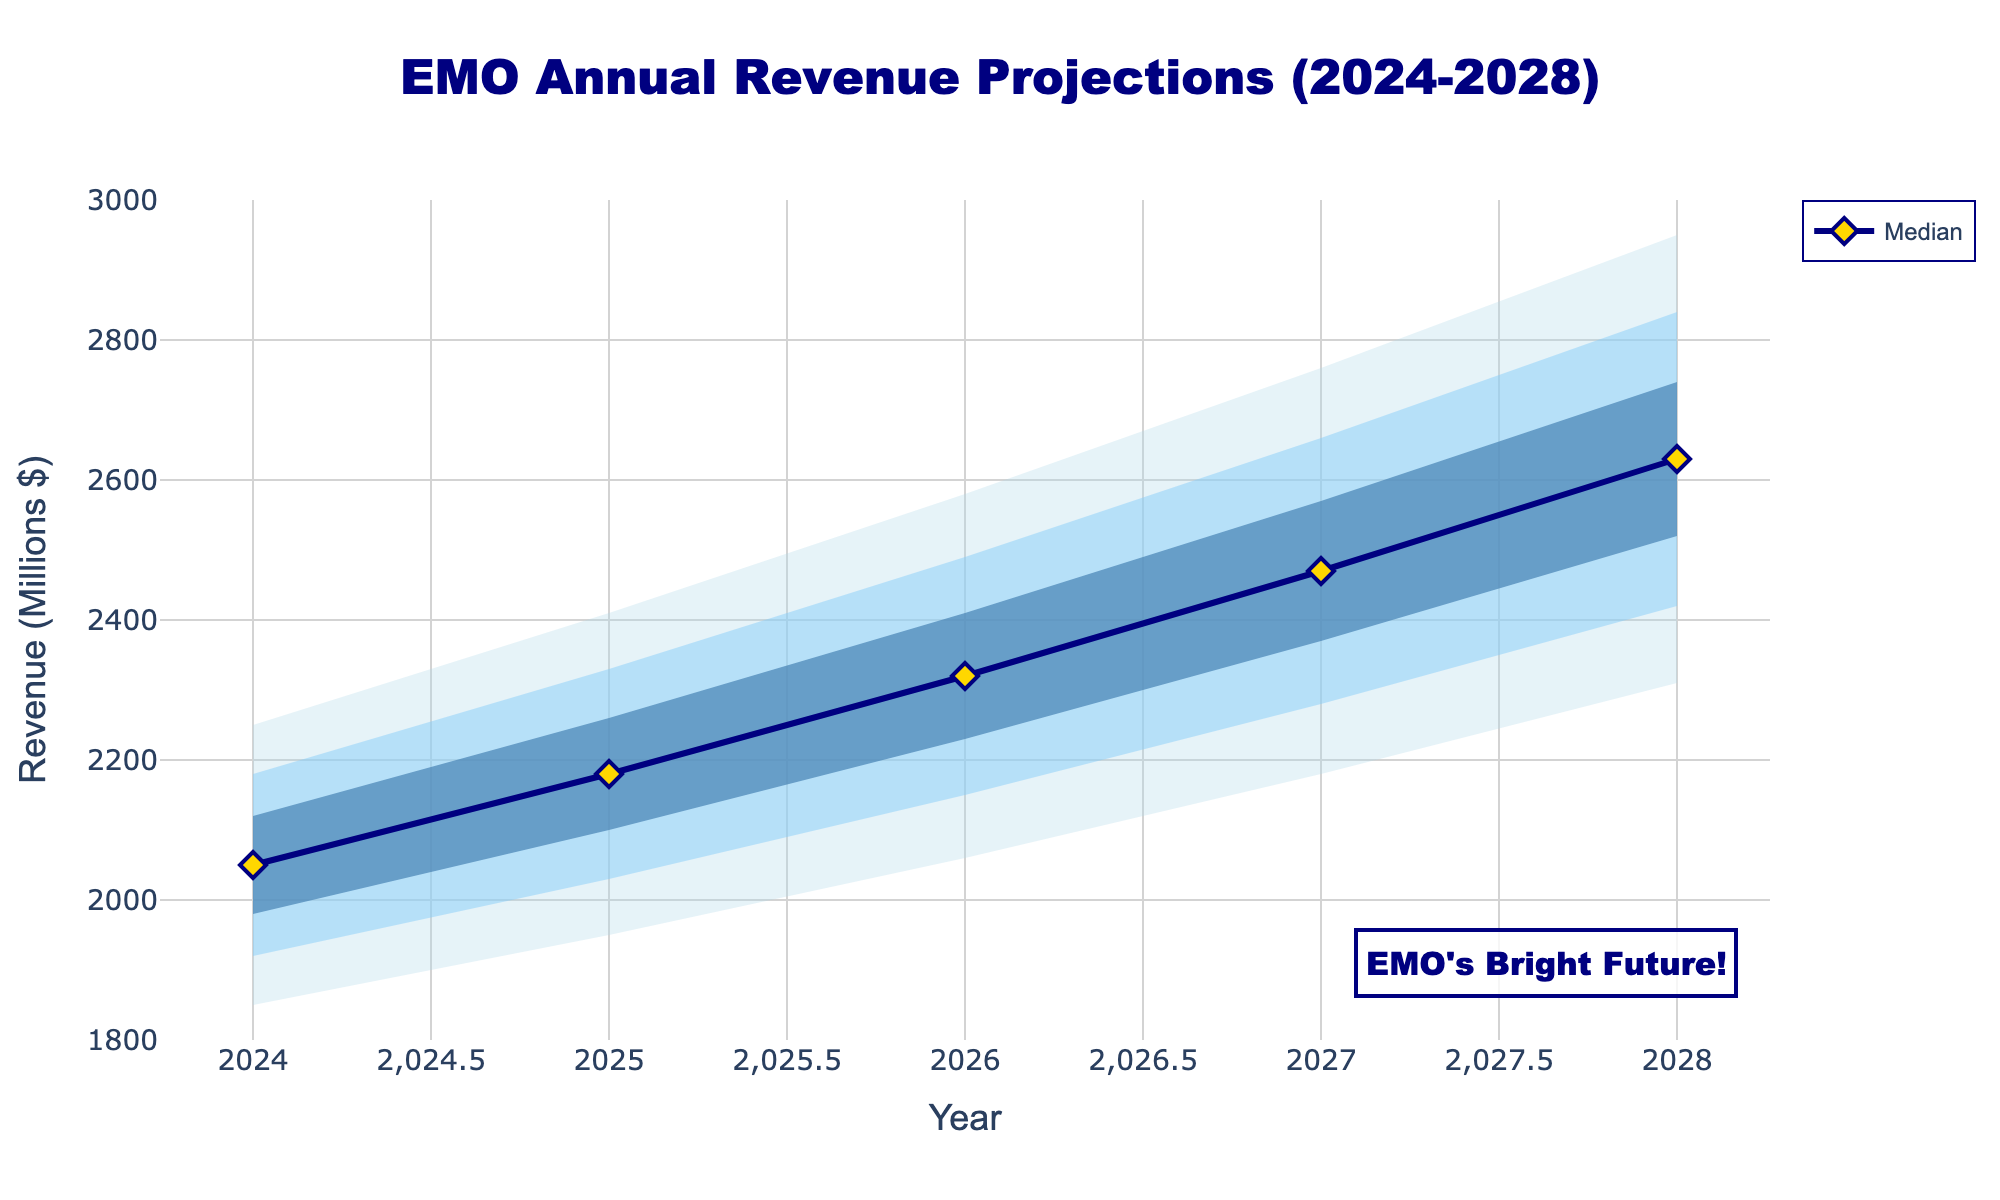What is the title of the chart? The title is written at the top center of the chart, typically in large font.
Answer: EMO Annual Revenue Projections (2024-2028) What is the median revenue projection for 2026? The median value for each year is plotted as a distinct line and marker on the chart. For 2026, locate the marker on the median line corresponding to the year.
Answer: 2320 (Millions $) By how much is the median revenue expected to increase from 2024 to 2028? Subtract the median revenue of 2024 from that of 2028: 2630 - 2050.
Answer: 580 (Millions $) In which year is the widest 95% confidence interval projected, and how wide is it? The 95% confidence interval is represented by the outermost shaded area. Calculate the width by subtracting the low value from the high value for each year. The widest interval is found by comparing these widths.
   For 2024: 2250 - 1850 = 400
   For 2025: 2410 - 1950 = 460
   For 2026: 2580 - 2060 = 520
   For 2027: 2760 - 2180 = 580
   For 2028: 2950 - 2310 = 640
Answer: 2028, 640 (Millions $) How does the median projection for 2028 compare to the high 60% confidence interval for 2026? Identify the median projection for 2028, which is 2630, and the high 60% projection for 2026, which is 2410. Compare the two values.
Answer: 2630 is greater than 2410 What is the expected revenue growth between 2025 and 2026 according to the median? Subtract the median revenue of 2025 from that of 2026: 2320 - 2180.
Answer: 140 (Millions $) What is the 80% confidence interval for the revenue projection in 2027? The 80% confidence interval is the range between the Low_80 and High_80 values for the year 2027. These values are plotted in the second outermost shaded area. Locate the values for 2027 in the respective columns.
Answer: 2280 (Low_80) to 2660 (High_80) Is the median revenue projection for 2024 within the 60% confidence interval for 2025? Compare the median revenue projection for 2024 (2050) with the 60% confidence interval range for 2025: 2100 to 2260. Check if 2050 falls within this range.
Answer: No What is the average of the median projections from 2024 to 2028? Sum the median values for each year and divide by the number of years.
   (2050 + 2180 + 2320 + 2470 + 2630) / 5 = 11650 / 5
Answer: 2330 (Millions $) Which year has the smallest difference between the Low_95 and Low_60 projections, and what is that difference? Calculate the difference between the Low_95 and Low_60 for each year, and identify the smallest value.
   For 2024: 1980 - 1850 = 130
   For 2025: 2100 - 1950 = 150
   For 2026: 2230 - 2060 = 170
   For 2027: 2370 - 2180 = 190
   For 2028: 2520 - 2310 = 210
Answer: 2024, 130 (Millions $) 